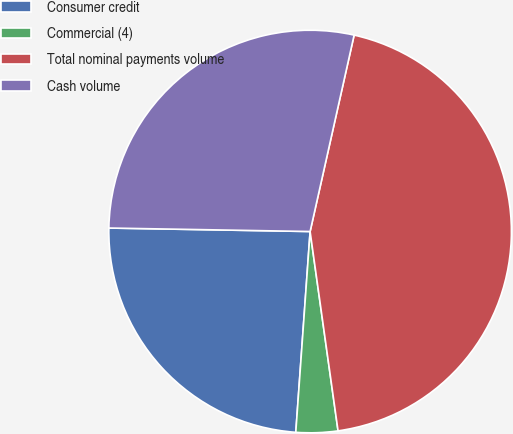Convert chart. <chart><loc_0><loc_0><loc_500><loc_500><pie_chart><fcel>Consumer credit<fcel>Commercial (4)<fcel>Total nominal payments volume<fcel>Cash volume<nl><fcel>24.14%<fcel>3.35%<fcel>44.27%<fcel>28.23%<nl></chart> 